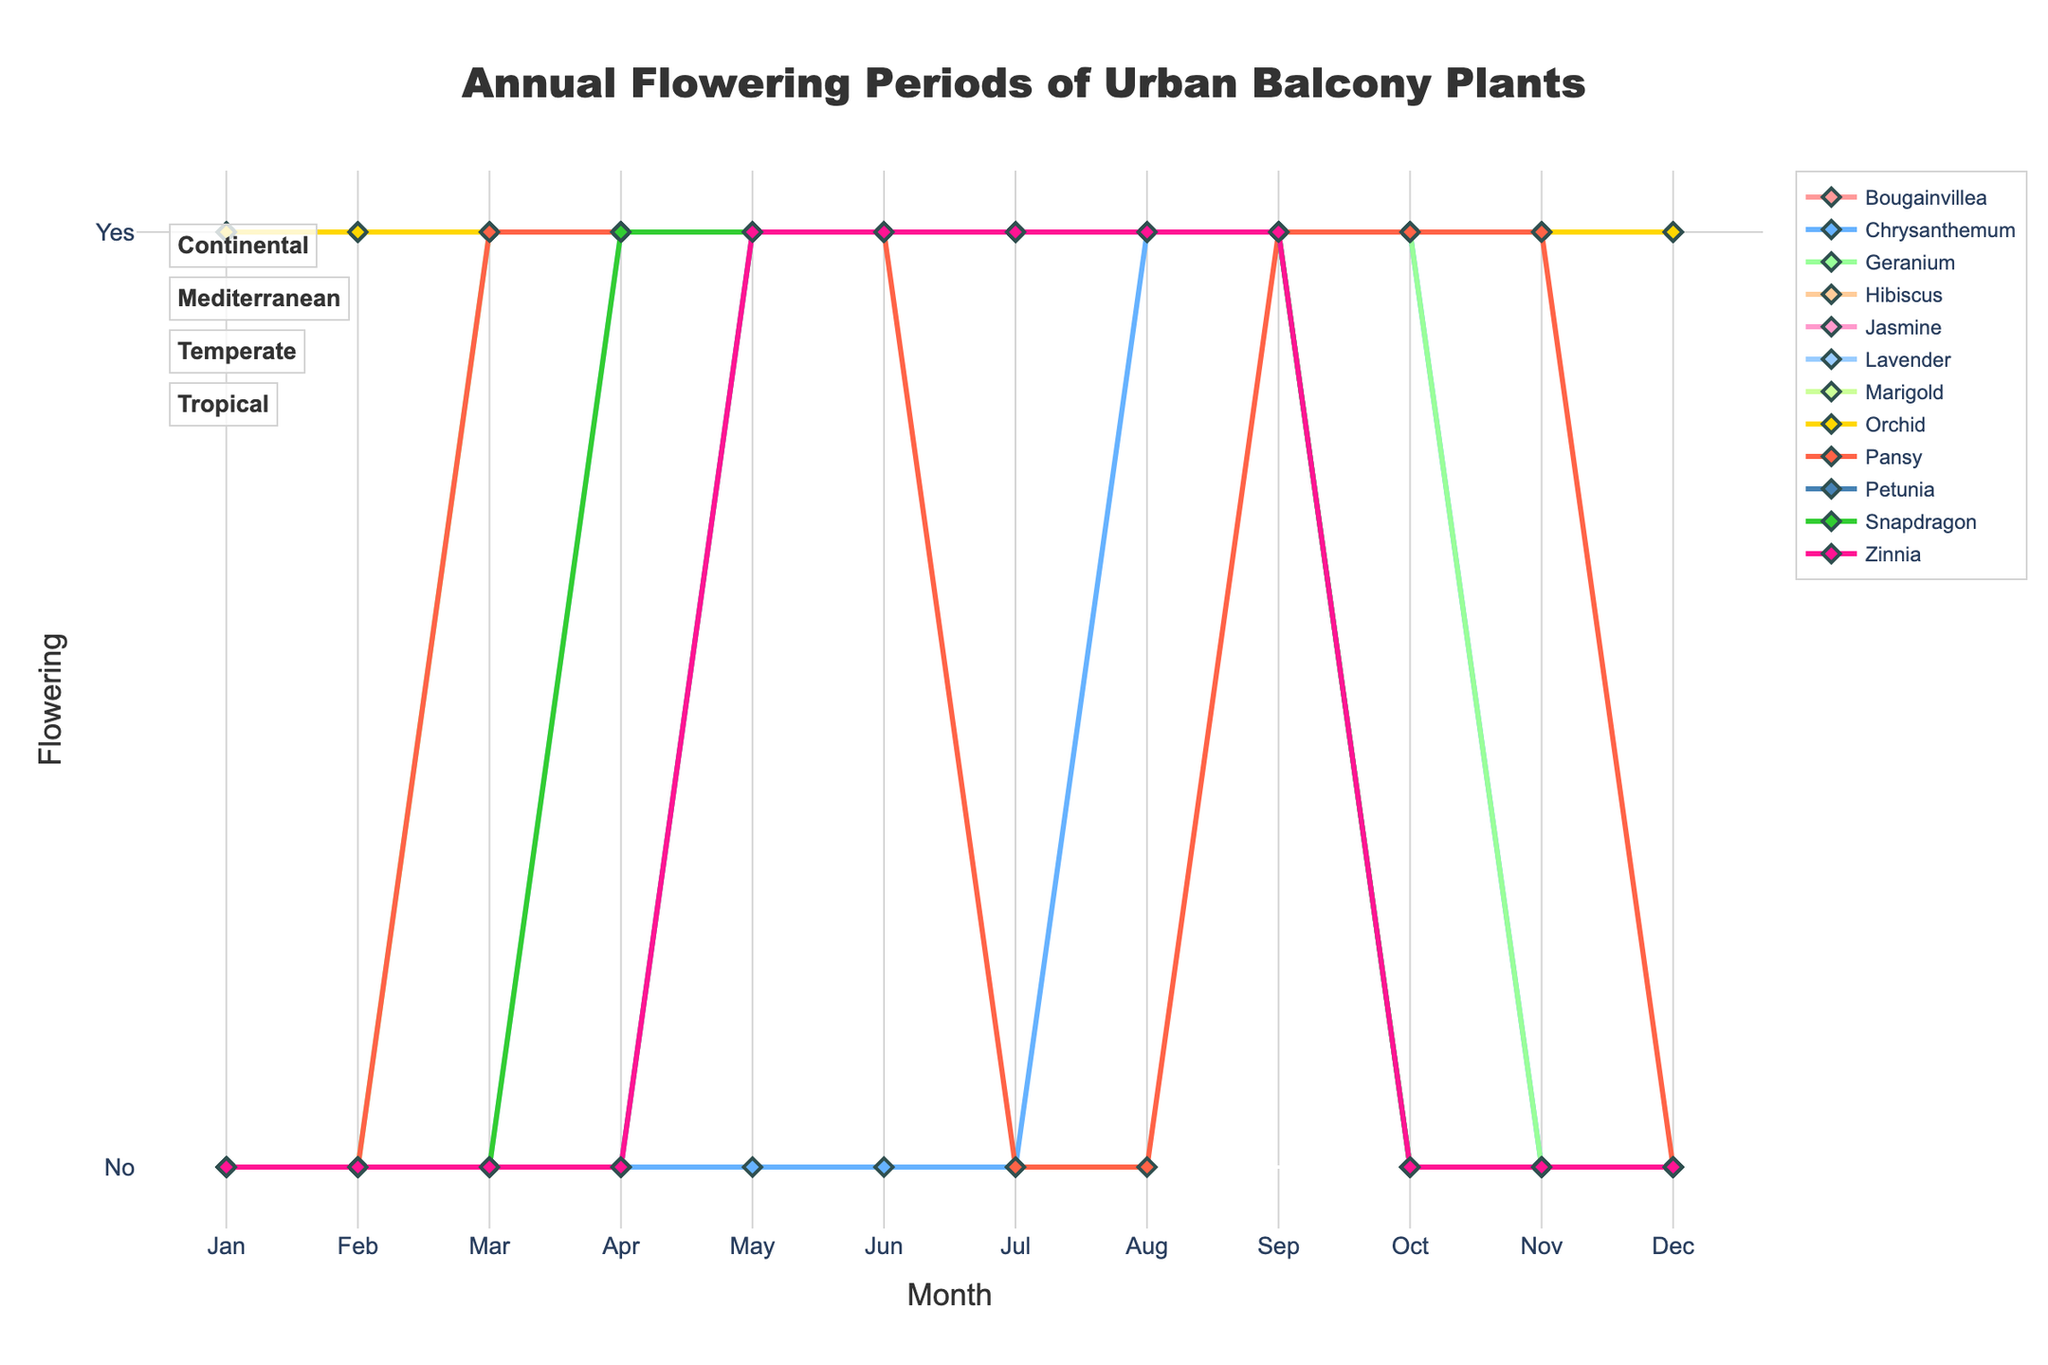What months do all Mediterranean plants flower? All Mediterranean plants flower in May to September. This is determined by observing the continuous blooming periods (marked by the lines with marker points) in the figure for Lavender, Geranium, and Bougainvillea.
Answer: May to September Which plant flowers all year round in the Continental climate zone? In the Continental climate zone, none of the plants (Petunia, Marigold, and Zinnia) flower all year round. This is determined by observing the line plots for these plants, which show flowering only in specific months and not across the whole year.
Answer: None How many months do Chrysanthemums flower in the Temperate climate zone? Chrysanthemums flower for 3 months: September, October, and November. This is determined by observing the months where the line for Chrysanthemums is at the 'Yes' level (y=1) indicating flowering.
Answer: 3 months Compare the flowering period of Jasmine in the Tropical climate zone with Lavender in the Mediterranean climate zone. Which one flowers for a longer period? Jasmine in the Tropical climate zone flowers all year round (12 months), whereas Lavender in the Mediterranean climate zone flowers from April to September (6 months).
Answer: Jasmine Considering the plants that flower all year round, how many such plants are there, and what climate zone are they in? The plants that flower all year round are Hibiscus, Orchid, and Jasmine, and they all belong to the Tropical climate zone. This is determined by observing the lines for these plants which are continuous through all months, indicating year-round flowering.
Answer: 3 plants, Tropical climate zone How many plants in the Temperate climate zone start flowering in March? Only Pansy starts flowering in March in the Temperate climate zone. This is identified by noting the markers on the Pansy line which indicate flowering beginning at March.
Answer: 1 plant What's the total duration (in months) for which Pansies flower annually in a Temperate climate zone? Pansies flower for a total of 8 months (March-May, September-November). This is determined by summing the distinct periods where there is flowering visible in the line for Pansies.
Answer: 8 months Between Marigold and Snapdragon, which plant flowers for a longer period in the year and what is the difference? Both Marigold and Snapdragon flower for 5 months. This can be observed by counting the segments of each line at the 'Yes' level for both plants.
Answer: Same duration, 0 months difference 